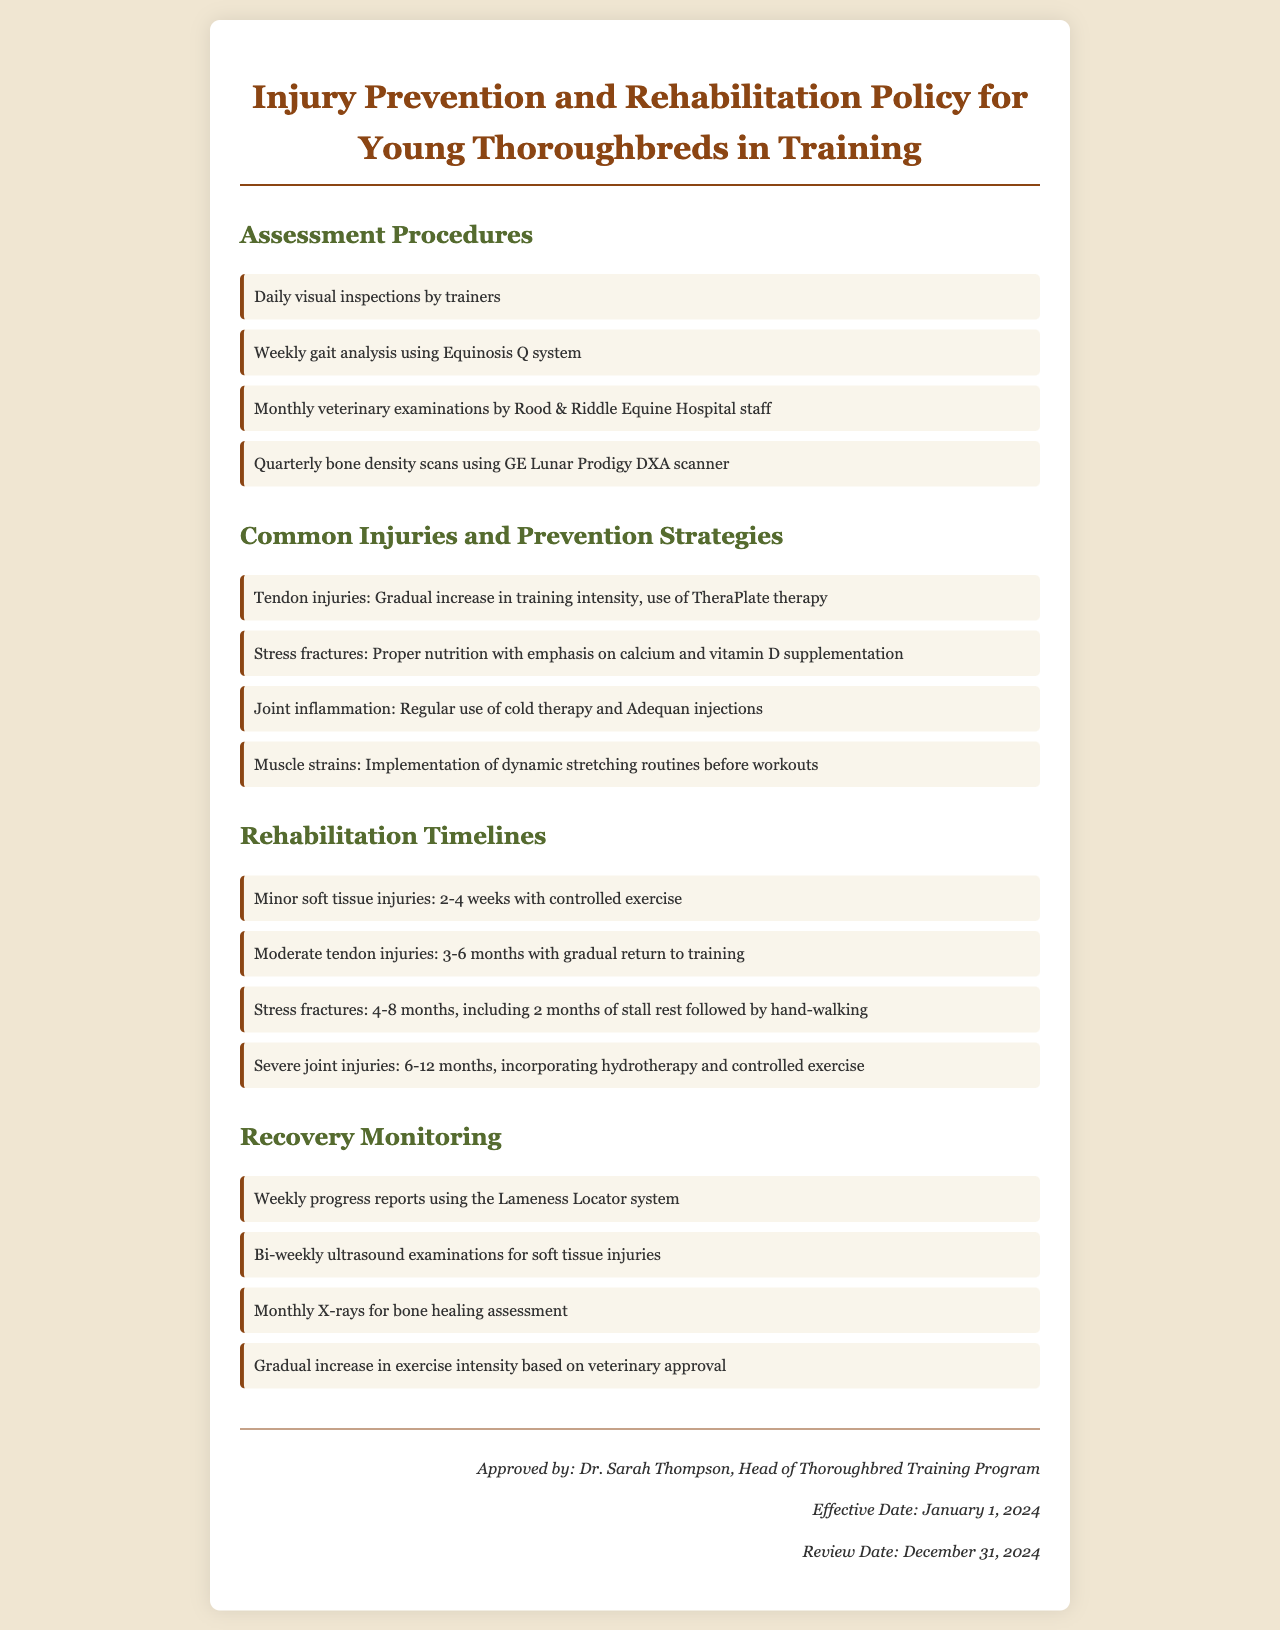What are the daily assessment procedures? The document lists the daily assessment procedures as daily visual inspections by trainers.
Answer: Daily visual inspections by trainers What is the timeline for minor soft tissue injuries? The timeline for rehabilitation of minor soft tissue injuries is specified in the document as 2-4 weeks with controlled exercise.
Answer: 2-4 weeks Which therapy is suggested for tendon injuries? The document mentions the use of TheraPlate therapy as a prevention strategy for tendon injuries.
Answer: TheraPlate therapy What type of analysis is performed weekly? The document states that a weekly gait analysis is performed using the Equinosis Q system.
Answer: Gait analysis using Equinosis Q system How often are veterinary examinations conducted? According to the document, veterinary examinations are conducted monthly by Rood & Riddle Equine Hospital staff.
Answer: Monthly What is emphasized in the nutrition for preventing stress fractures? The document emphasizes proper nutrition with an emphasis on calcium and vitamin D supplementation for preventing stress fractures.
Answer: Calcium and vitamin D supplementation What is the recovery timeline for severe joint injuries? The timeline for rehabilitation of severe joint injuries is stated as 6-12 months, incorporating hydrotherapy and controlled exercise.
Answer: 6-12 months How are recovery progress reports prepared? The document describes that recovery progress reports are prepared weekly using the Lameness Locator system.
Answer: Weekly progress reports using the Lameness Locator system When was the policy approved? The document indicates that the policy was approved by Dr. Sarah Thompson.
Answer: Dr. Sarah Thompson 